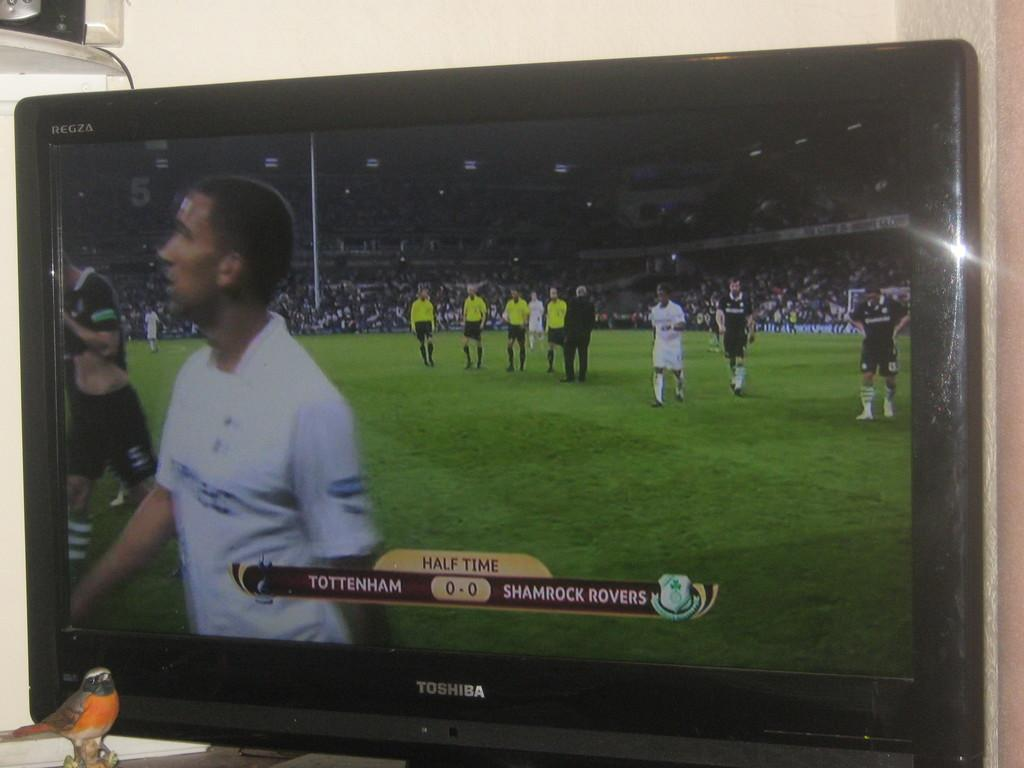Provide a one-sentence caption for the provided image. A picture of a television showing the half time score of a Tottenham v Shamrock Rovers soccer match. 